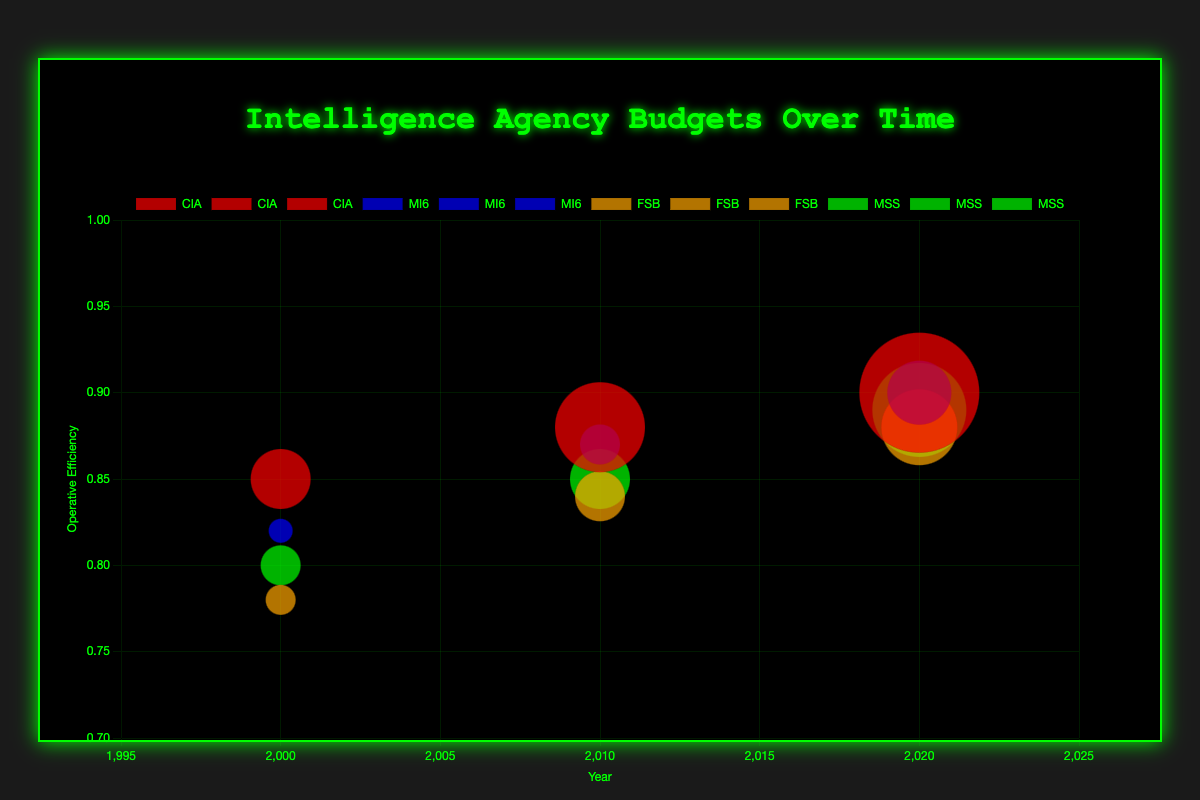What is the title of the bubble chart? The title of the chart is displayed at the top center in green text with a glowing effect. It reads "Intelligence Agency Budgets Over Time."
Answer: Intelligence Agency Budgets Over Time Which agency has the largest budget in 2020? Look for the bubbles in the year 2020 and compare their sizes, which corresponds to the budgets. The largest bubble is for the CIA.
Answer: CIA How does the operative efficiency of the CIA in 2000 compare to that in 2020? Find the CIA bubbles for the years 2000 and 2020. The operative efficiency is on the y-axis. In 2000, the CIA's efficiency is 0.85, while in 2020 it is 0.9, showing an increase.
Answer: It increased from 0.85 to 0.9 What is the trend in the success rate of MSS from 2000 to 2020? Check the success rates (not directly shown but inferred from budgets and operative efficiency) plotted over the years 2000 to 2020 for MSS. The success rate has increased from 0.73 in 2000 to 0.79 in 2020.
Answer: It increased Compare the budgets of FSB and MI6 in 2010. Which is higher? Identify the bubbles for FSB and MI6 in 2010 and compare their sizes. The FSB's budget is $2.5 billion while MI6's budget is $2 billion.
Answer: FSB What is the total budget for CIA and MI6 combined in 2020? Find the budgets for CIA and MI6 in 2020 and sum them. CIA has $6 billion and MI6 has $3.2 billion, totaling $9.2 billion.
Answer: $9.2 billion Which agency shows the highest operative efficiency in 2010? Look at the y-axis values for 2010. The highest operative efficiency in 2010 belongs to MI6 with 0.87.
Answer: MI6 How did the budget of the FSB change from 2000 to 2020? Compare the sizes of the bubbles for FSB in 2000 and 2020. The budget increased from $1.5 billion in 2000 to $3.8 billion in 2020.
Answer: It more than doubled What would be the average operative efficiency of all agencies in 2020? Find operative efficiencies of all agencies in 2020: CIA (0.9), MI6 (0.9), FSB (0.88), MSS (0.89). Sum these values and divide by 4. (0.9 + 0.9 + 0.88 + 0.89) / 4 = 0.8925
Answer: 0.8925 